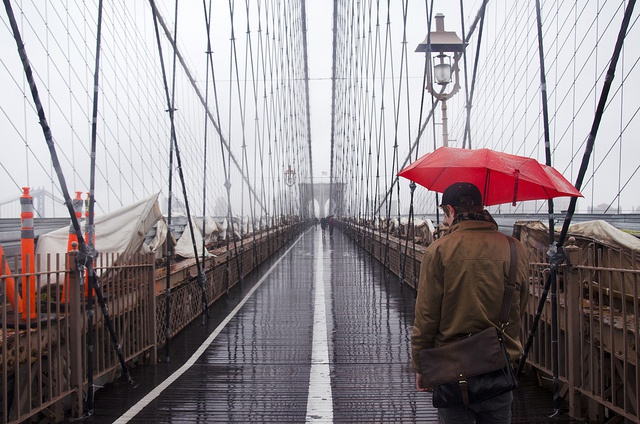Describe the objects in this image and their specific colors. I can see people in white, black, maroon, and brown tones, umbrella in white, brown, salmon, lightpink, and lightgray tones, handbag in white, black, and gray tones, people in white, gray, and black tones, and people in white, black, and gray tones in this image. 